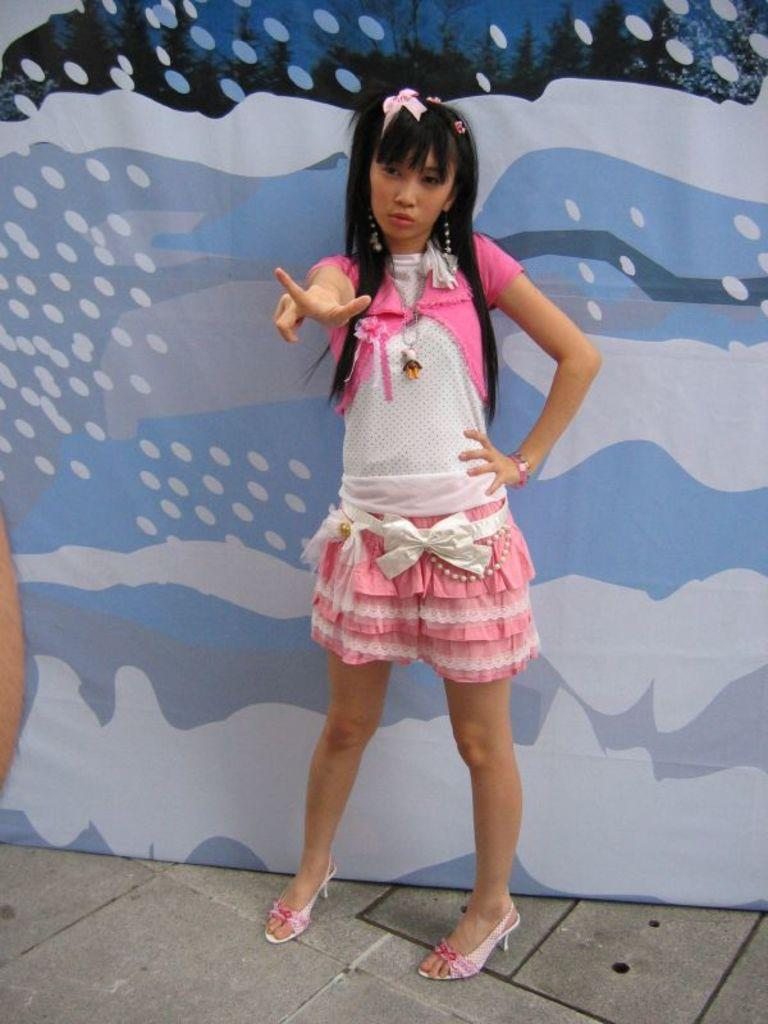Who is present in the image? There is a woman in the image. What is the woman wearing? The woman is wearing a dress. What is the woman's position in relation to the ground? The woman is standing on the ground. What can be seen in the background of the image? There is a wall with paintings in the background of the image. What type of slip can be seen on the woman's feet in the image? There is no slip visible on the woman's feet in the image. How many birds are in the flock that is flying in the image? There are no birds or flocks present in the image; it features a woman standing in front of a wall with paintings. 